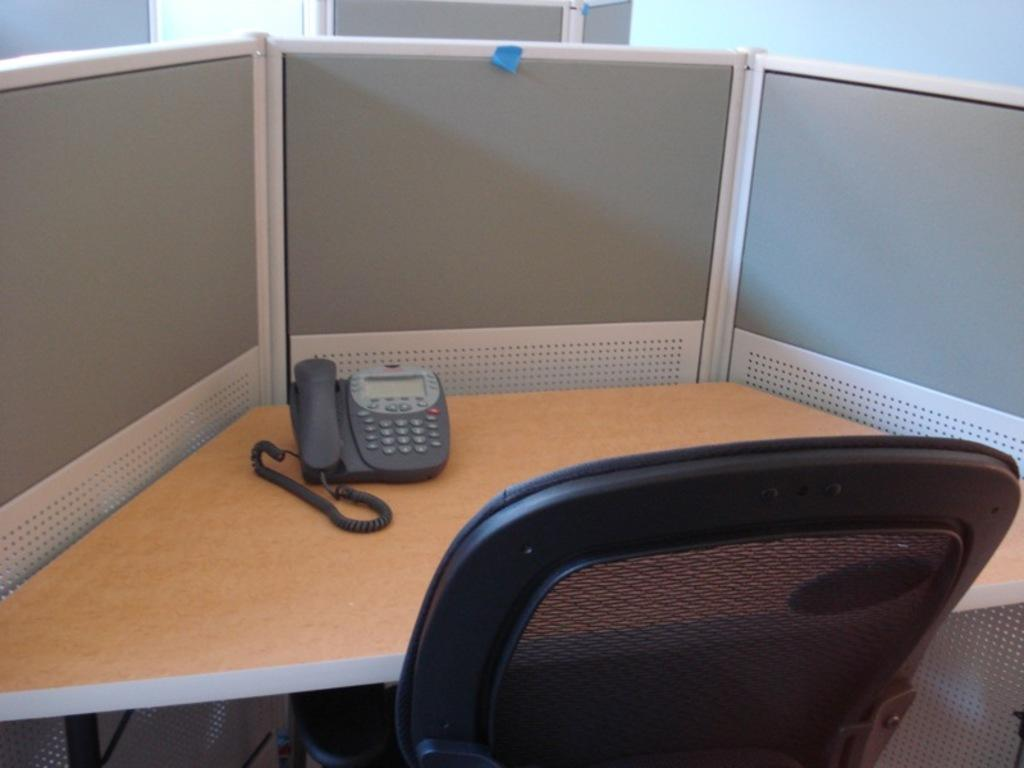What type of furniture is present in the image? There is a desk and a chair in the image. What object can be seen on the desk? There is a telephone on the desk. Are there any other desks visible in the image? Yes, there is another desk in the background of the image. What color is the wall in the top right corner of the image? The wall in the top right corner of the image is painted white. Is there any rain visible in the image? No, there is no rain present in the image. What type of writing can be seen on the desk? There is no writing visible on the desk in the image. 